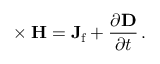<formula> <loc_0><loc_0><loc_500><loc_500>\nabla \times H = J _ { f } + { \frac { \partial D } { \partial t } } \, .</formula> 